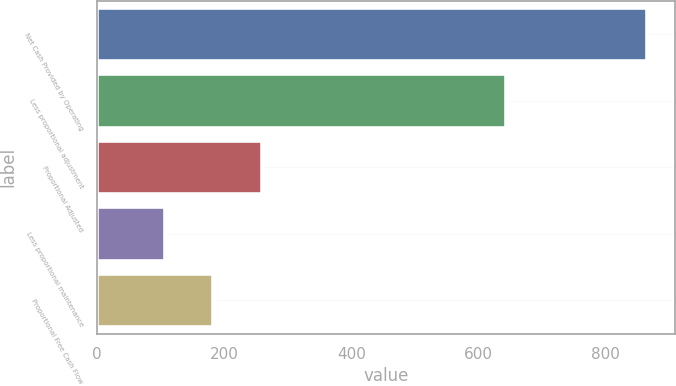Convert chart to OTSL. <chart><loc_0><loc_0><loc_500><loc_500><bar_chart><fcel>Net Cash Provided by Operating<fcel>Less proportional adjustment<fcel>Proportional Adjusted<fcel>Less proportional maintenance<fcel>Proportional Free Cash Flow<nl><fcel>866<fcel>643<fcel>258.8<fcel>107<fcel>182.9<nl></chart> 